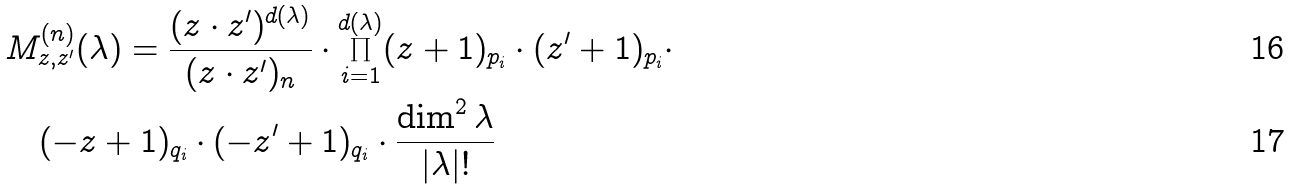Convert formula to latex. <formula><loc_0><loc_0><loc_500><loc_500>& M ^ { ( n ) } _ { z , z ^ { \prime } } ( \lambda ) = \frac { ( z \cdot z ^ { \prime } ) ^ { d ( \lambda ) } } { ( z \cdot z ^ { \prime } ) _ { n } } \cdot \prod ^ { d ( \lambda ) } _ { i = 1 } ( z + 1 ) _ { p _ { i } } \cdot ( z ^ { \prime } + 1 ) _ { p _ { i } } \cdot \\ & \quad ( - z + 1 ) _ { q _ { i } } \cdot ( - z ^ { \prime } + 1 ) _ { q _ { i } } \cdot \frac { \dim ^ { 2 } \lambda } { | \lambda | ! }</formula> 